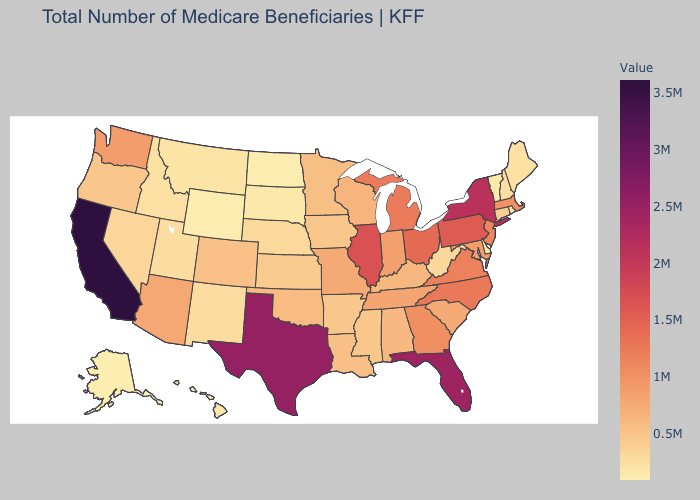Does Tennessee have a higher value than Rhode Island?
Give a very brief answer. Yes. Does the map have missing data?
Quick response, please. No. Which states have the highest value in the USA?
Concise answer only. California. Which states have the lowest value in the USA?
Concise answer only. Alaska. Does the map have missing data?
Be succinct. No. Does the map have missing data?
Short answer required. No. Among the states that border North Dakota , which have the highest value?
Write a very short answer. Minnesota. Among the states that border New York , does Pennsylvania have the highest value?
Give a very brief answer. Yes. 